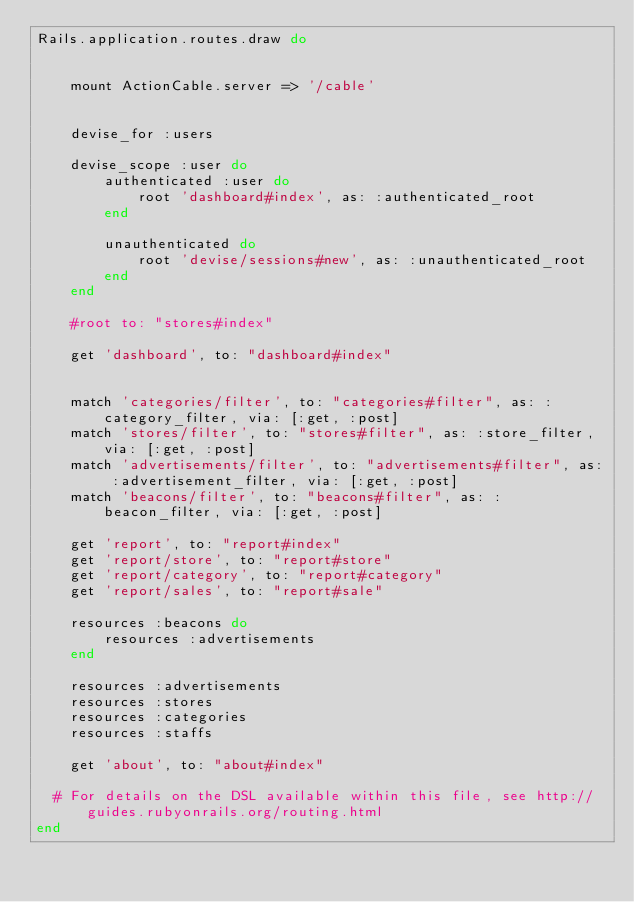Convert code to text. <code><loc_0><loc_0><loc_500><loc_500><_Ruby_>Rails.application.routes.draw do


    mount ActionCable.server => '/cable'


	devise_for :users

    devise_scope :user do
        authenticated :user do
            root 'dashboard#index', as: :authenticated_root
        end

        unauthenticated do
            root 'devise/sessions#new', as: :unauthenticated_root
        end
    end

	#root to: "stores#index"

    get 'dashboard', to: "dashboard#index"
    

    match 'categories/filter', to: "categories#filter", as: :category_filter, via: [:get, :post]
    match 'stores/filter', to: "stores#filter", as: :store_filter, via: [:get, :post]
    match 'advertisements/filter', to: "advertisements#filter", as: :advertisement_filter, via: [:get, :post]
    match 'beacons/filter', to: "beacons#filter", as: :beacon_filter, via: [:get, :post]
    
    get 'report', to: "report#index"
    get 'report/store', to: "report#store"
    get 'report/category', to: "report#category"
    get 'report/sales', to: "report#sale"

    resources :beacons do
        resources :advertisements
    end

    resources :advertisements
    resources :stores
    resources :categories
    resources :staffs

    get 'about', to: "about#index"

  # For details on the DSL available within this file, see http://guides.rubyonrails.org/routing.html
end
</code> 